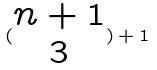<formula> <loc_0><loc_0><loc_500><loc_500>( \begin{matrix} n + 1 \\ 3 \end{matrix} ) + 1</formula> 